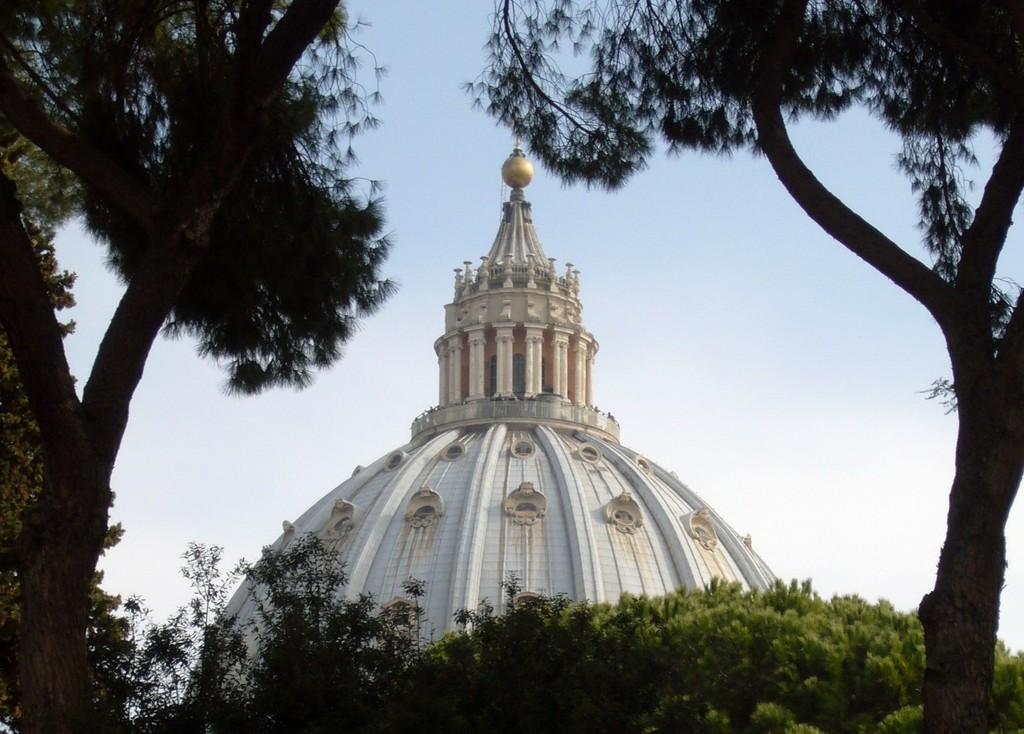What type of structure is present in the image? There is a building in the image. What type of vegetation can be seen in the image? There are trees and plants in the image. What part of the natural environment is visible in the image? The sky is visible in the image. How many pigs are visible in the image? There are no pigs present in the image. What type of list can be seen in the image? There is no list present in the image. 